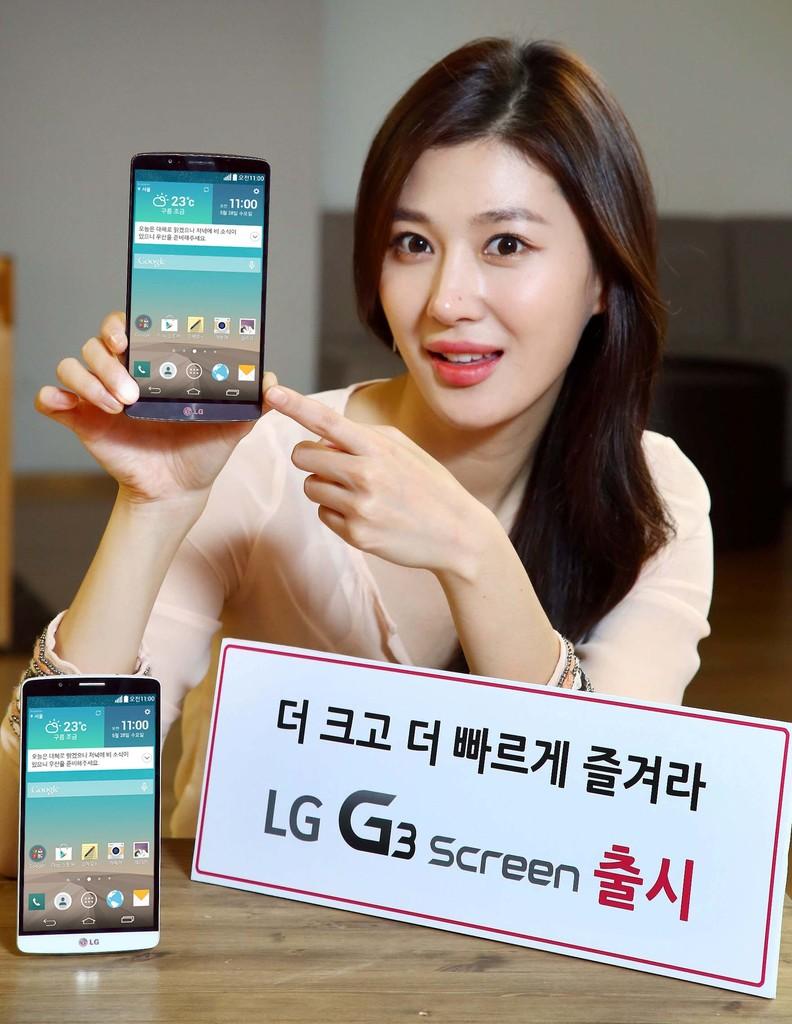What brand is the phone?
Provide a succinct answer. Lg. What kind of screen?
Offer a very short reply. Lg g3. 